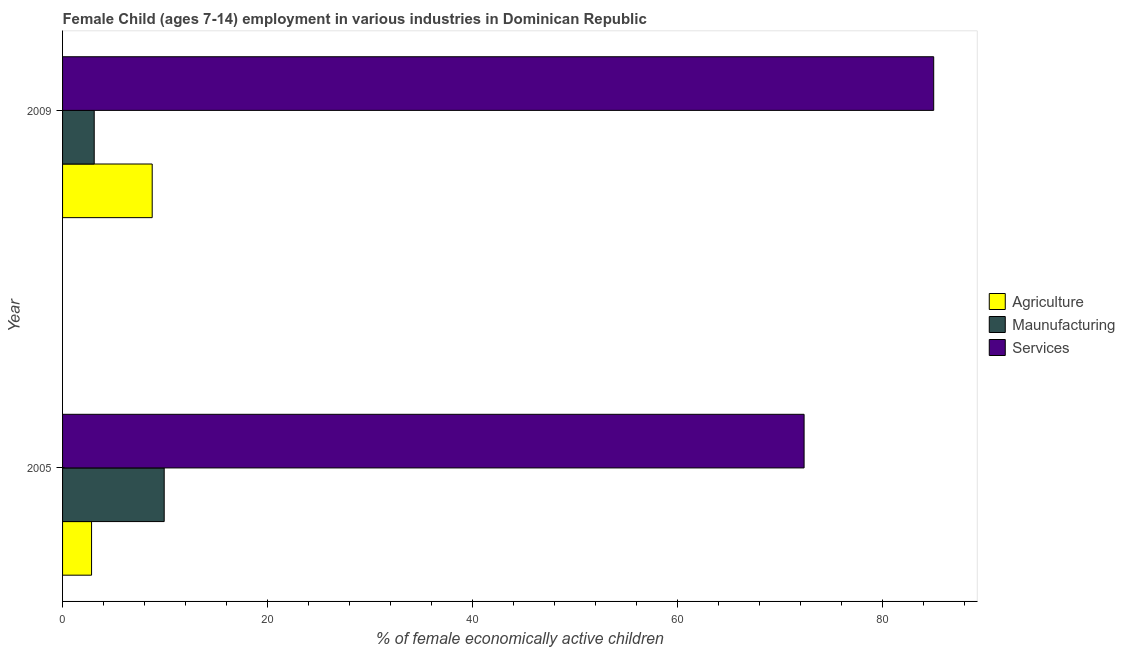How many different coloured bars are there?
Provide a succinct answer. 3. How many bars are there on the 2nd tick from the top?
Offer a terse response. 3. What is the percentage of economically active children in manufacturing in 2009?
Your response must be concise. 3.09. Across all years, what is the maximum percentage of economically active children in agriculture?
Offer a terse response. 8.75. Across all years, what is the minimum percentage of economically active children in manufacturing?
Offer a terse response. 3.09. What is the total percentage of economically active children in agriculture in the graph?
Your answer should be very brief. 11.58. What is the difference between the percentage of economically active children in services in 2005 and that in 2009?
Provide a succinct answer. -12.65. What is the difference between the percentage of economically active children in manufacturing in 2009 and the percentage of economically active children in agriculture in 2005?
Ensure brevity in your answer.  0.26. What is the average percentage of economically active children in agriculture per year?
Give a very brief answer. 5.79. In the year 2009, what is the difference between the percentage of economically active children in services and percentage of economically active children in manufacturing?
Your response must be concise. 81.94. In how many years, is the percentage of economically active children in manufacturing greater than 28 %?
Keep it short and to the point. 0. What is the ratio of the percentage of economically active children in manufacturing in 2005 to that in 2009?
Offer a very short reply. 3.21. In how many years, is the percentage of economically active children in services greater than the average percentage of economically active children in services taken over all years?
Your response must be concise. 1. What does the 1st bar from the top in 2005 represents?
Ensure brevity in your answer.  Services. What does the 2nd bar from the bottom in 2005 represents?
Provide a short and direct response. Maunufacturing. Is it the case that in every year, the sum of the percentage of economically active children in agriculture and percentage of economically active children in manufacturing is greater than the percentage of economically active children in services?
Your answer should be very brief. No. Are the values on the major ticks of X-axis written in scientific E-notation?
Your response must be concise. No. Does the graph contain grids?
Offer a terse response. No. How are the legend labels stacked?
Keep it short and to the point. Vertical. What is the title of the graph?
Your answer should be very brief. Female Child (ages 7-14) employment in various industries in Dominican Republic. What is the label or title of the X-axis?
Make the answer very short. % of female economically active children. What is the % of female economically active children of Agriculture in 2005?
Your answer should be compact. 2.83. What is the % of female economically active children in Maunufacturing in 2005?
Your response must be concise. 9.92. What is the % of female economically active children in Services in 2005?
Keep it short and to the point. 72.38. What is the % of female economically active children of Agriculture in 2009?
Offer a very short reply. 8.75. What is the % of female economically active children of Maunufacturing in 2009?
Make the answer very short. 3.09. What is the % of female economically active children in Services in 2009?
Provide a succinct answer. 85.03. Across all years, what is the maximum % of female economically active children of Agriculture?
Offer a terse response. 8.75. Across all years, what is the maximum % of female economically active children in Maunufacturing?
Make the answer very short. 9.92. Across all years, what is the maximum % of female economically active children of Services?
Provide a short and direct response. 85.03. Across all years, what is the minimum % of female economically active children of Agriculture?
Provide a short and direct response. 2.83. Across all years, what is the minimum % of female economically active children in Maunufacturing?
Give a very brief answer. 3.09. Across all years, what is the minimum % of female economically active children of Services?
Give a very brief answer. 72.38. What is the total % of female economically active children in Agriculture in the graph?
Give a very brief answer. 11.58. What is the total % of female economically active children in Maunufacturing in the graph?
Make the answer very short. 13.01. What is the total % of female economically active children in Services in the graph?
Offer a very short reply. 157.41. What is the difference between the % of female economically active children of Agriculture in 2005 and that in 2009?
Offer a very short reply. -5.92. What is the difference between the % of female economically active children in Maunufacturing in 2005 and that in 2009?
Give a very brief answer. 6.83. What is the difference between the % of female economically active children in Services in 2005 and that in 2009?
Ensure brevity in your answer.  -12.65. What is the difference between the % of female economically active children of Agriculture in 2005 and the % of female economically active children of Maunufacturing in 2009?
Offer a very short reply. -0.26. What is the difference between the % of female economically active children in Agriculture in 2005 and the % of female economically active children in Services in 2009?
Your response must be concise. -82.2. What is the difference between the % of female economically active children in Maunufacturing in 2005 and the % of female economically active children in Services in 2009?
Give a very brief answer. -75.11. What is the average % of female economically active children of Agriculture per year?
Make the answer very short. 5.79. What is the average % of female economically active children in Maunufacturing per year?
Ensure brevity in your answer.  6.5. What is the average % of female economically active children in Services per year?
Your answer should be very brief. 78.7. In the year 2005, what is the difference between the % of female economically active children of Agriculture and % of female economically active children of Maunufacturing?
Your answer should be very brief. -7.09. In the year 2005, what is the difference between the % of female economically active children of Agriculture and % of female economically active children of Services?
Ensure brevity in your answer.  -69.55. In the year 2005, what is the difference between the % of female economically active children in Maunufacturing and % of female economically active children in Services?
Provide a short and direct response. -62.46. In the year 2009, what is the difference between the % of female economically active children in Agriculture and % of female economically active children in Maunufacturing?
Provide a short and direct response. 5.66. In the year 2009, what is the difference between the % of female economically active children in Agriculture and % of female economically active children in Services?
Your answer should be compact. -76.28. In the year 2009, what is the difference between the % of female economically active children of Maunufacturing and % of female economically active children of Services?
Your answer should be compact. -81.94. What is the ratio of the % of female economically active children in Agriculture in 2005 to that in 2009?
Your answer should be compact. 0.32. What is the ratio of the % of female economically active children of Maunufacturing in 2005 to that in 2009?
Your answer should be very brief. 3.21. What is the ratio of the % of female economically active children in Services in 2005 to that in 2009?
Ensure brevity in your answer.  0.85. What is the difference between the highest and the second highest % of female economically active children of Agriculture?
Your answer should be compact. 5.92. What is the difference between the highest and the second highest % of female economically active children in Maunufacturing?
Your response must be concise. 6.83. What is the difference between the highest and the second highest % of female economically active children of Services?
Keep it short and to the point. 12.65. What is the difference between the highest and the lowest % of female economically active children in Agriculture?
Your answer should be compact. 5.92. What is the difference between the highest and the lowest % of female economically active children in Maunufacturing?
Provide a short and direct response. 6.83. What is the difference between the highest and the lowest % of female economically active children of Services?
Offer a very short reply. 12.65. 